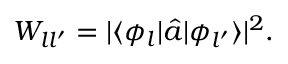<formula> <loc_0><loc_0><loc_500><loc_500>\begin{array} { r } { W _ { l l ^ { \prime } } = | \langle \phi _ { l } | \hat { a } | \phi _ { l ^ { \prime } } \rangle | ^ { 2 } . } \end{array}</formula> 